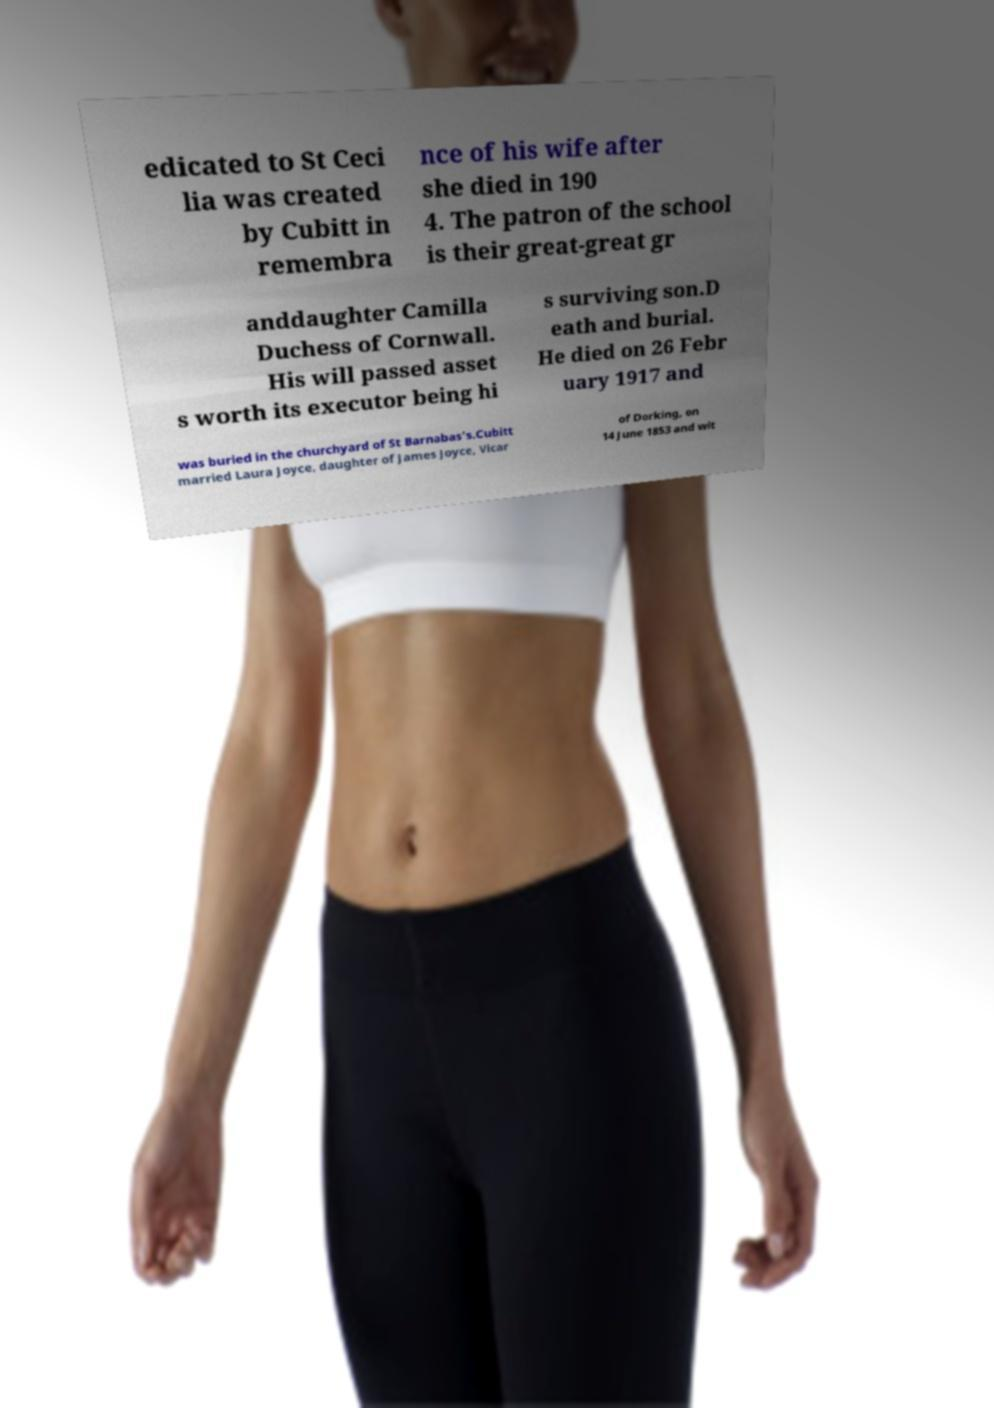Could you extract and type out the text from this image? edicated to St Ceci lia was created by Cubitt in remembra nce of his wife after she died in 190 4. The patron of the school is their great-great gr anddaughter Camilla Duchess of Cornwall. His will passed asset s worth its executor being hi s surviving son.D eath and burial. He died on 26 Febr uary 1917 and was buried in the churchyard of St Barnabas's.Cubitt married Laura Joyce, daughter of James Joyce, Vicar of Dorking, on 14 June 1853 and wit 